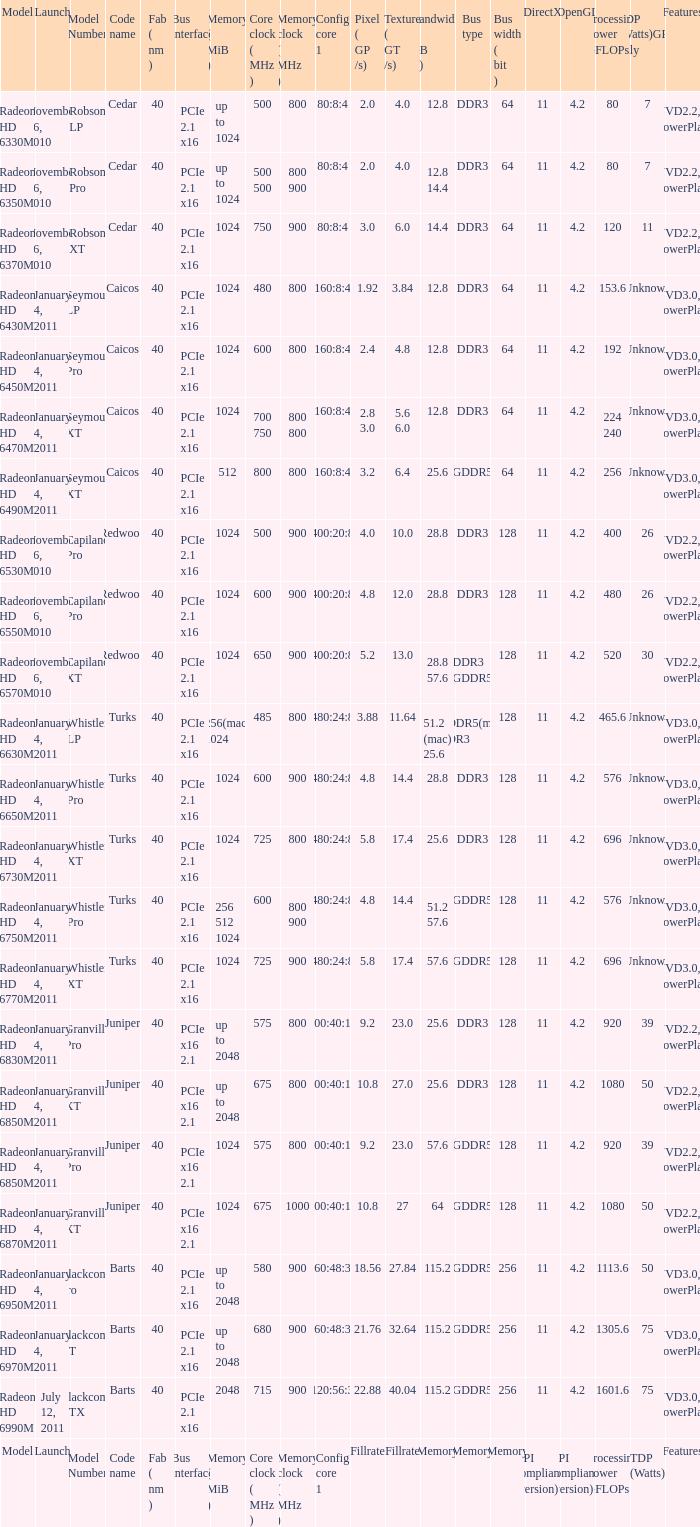What is the value for congi core 1 if the code name is Redwood and core clock(mhz) is 500? 400:20:8. 